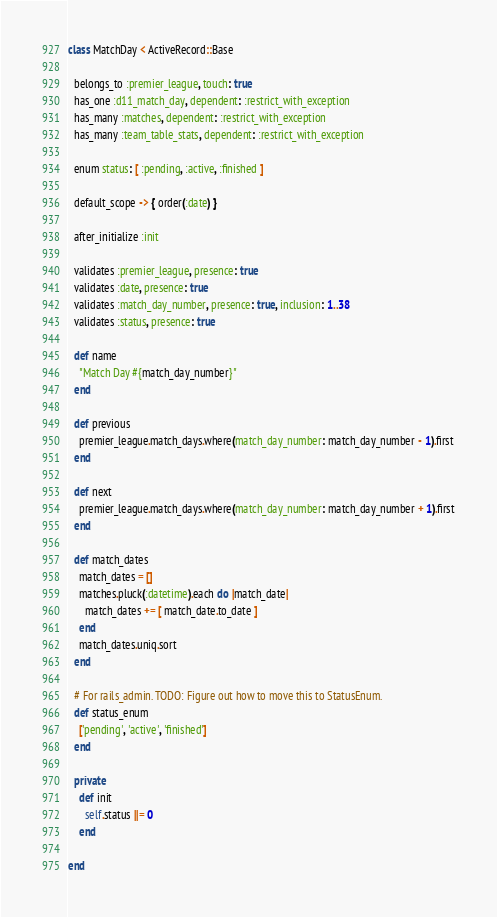<code> <loc_0><loc_0><loc_500><loc_500><_Ruby_>class MatchDay < ActiveRecord::Base
  
  belongs_to :premier_league, touch: true
  has_one :d11_match_day, dependent: :restrict_with_exception
  has_many :matches, dependent: :restrict_with_exception
  has_many :team_table_stats, dependent: :restrict_with_exception
  
  enum status: [ :pending, :active, :finished ]
  
  default_scope -> { order(:date) }

  after_initialize :init

  validates :premier_league, presence: true
  validates :date, presence: true
  validates :match_day_number, presence: true, inclusion: 1..38
  validates :status, presence: true    

  def name
    "Match Day #{match_day_number}"
  end
  
  def previous
    premier_league.match_days.where(match_day_number: match_day_number - 1).first
  end

  def next
    premier_league.match_days.where(match_day_number: match_day_number + 1).first
  end

  def match_dates
    match_dates = []
    matches.pluck(:datetime).each do |match_date|
      match_dates += [ match_date.to_date ]
    end
    match_dates.uniq.sort
  end

  # For rails_admin. TODO: Figure out how to move this to StatusEnum.
  def status_enum
    ['pending', 'active', 'finished']
  end    
  
  private
    def init
      self.status ||= 0
    end
  
end
</code> 